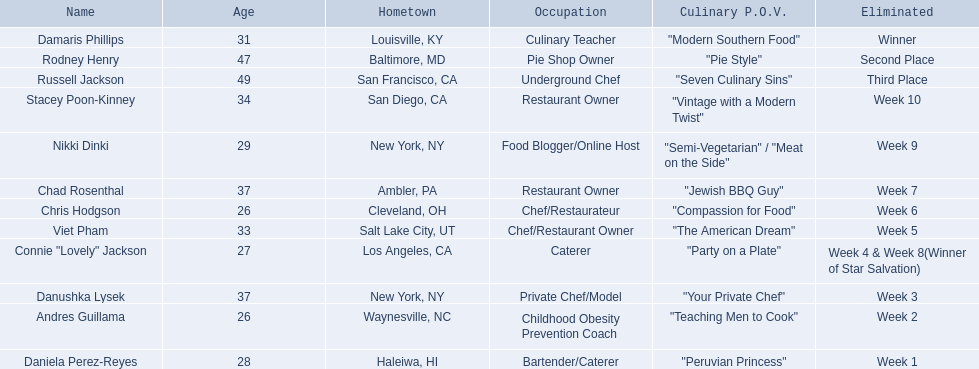Who are the listed food network star contestants? Damaris Phillips, Rodney Henry, Russell Jackson, Stacey Poon-Kinney, Nikki Dinki, Chad Rosenthal, Chris Hodgson, Viet Pham, Connie "Lovely" Jackson, Danushka Lysek, Andres Guillama, Daniela Perez-Reyes. Of those who had the longest p.o.v title? Nikki Dinki. 